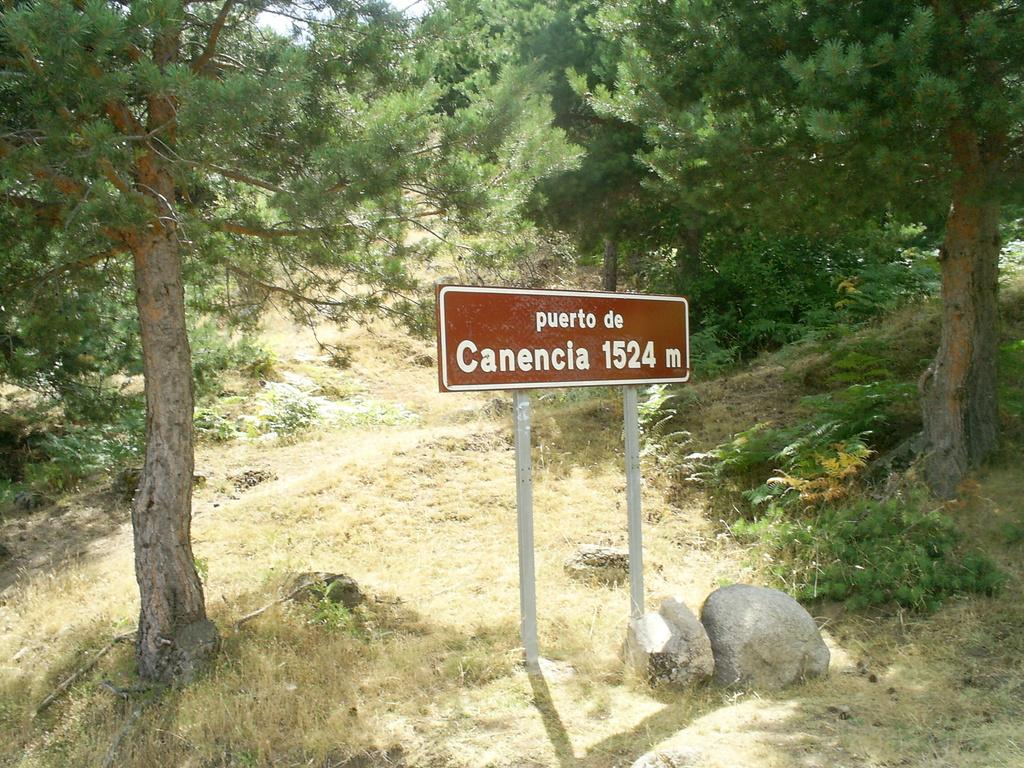What is the main object in the image with poles? There is a name board with poles in the image. What type of natural elements can be seen in the image? Stones, grass, plants, and trees are visible in the image. What type of pies are being served on the name board in the image? There are no pies present in the image; it features a name board with poles and natural elements. Can you see a locket hanging from the trees in the image? There is no locket visible in the image; it only shows a name board, stones, grass, plants, and trees. 